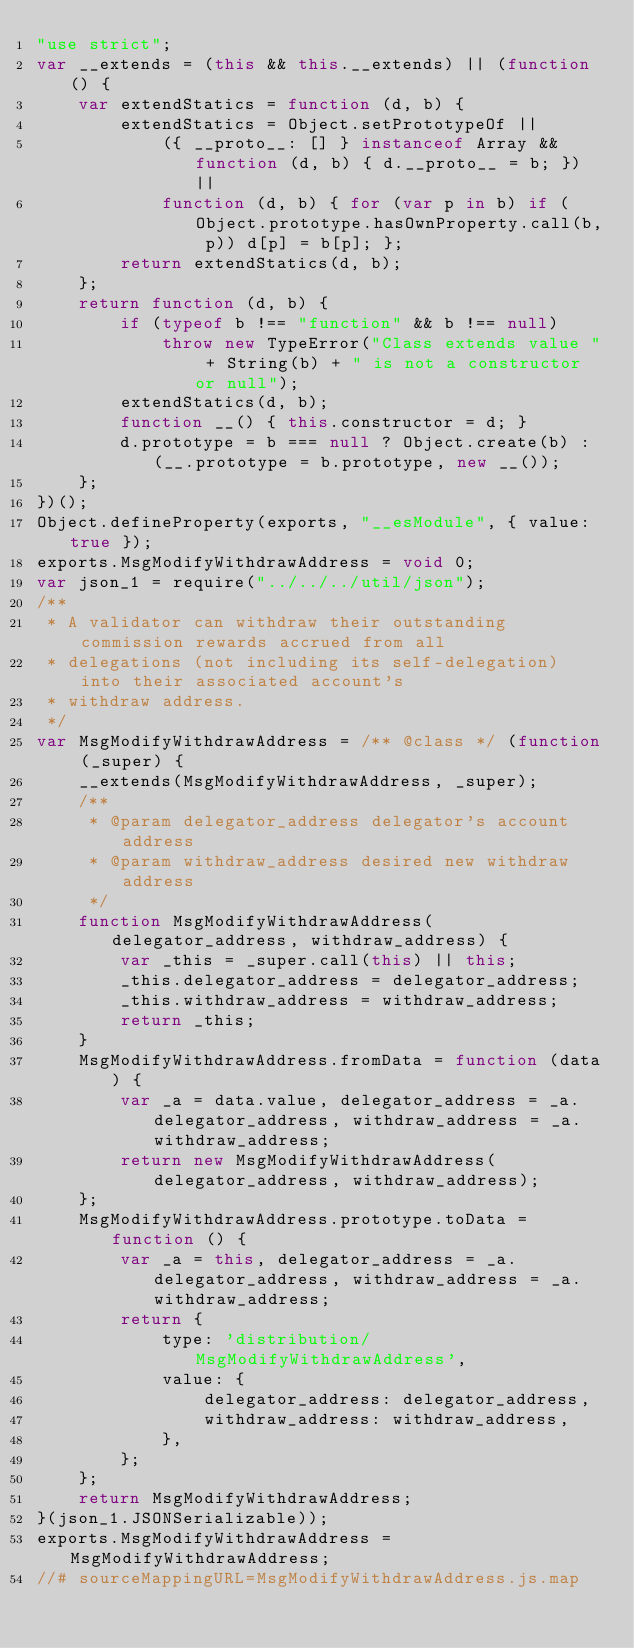<code> <loc_0><loc_0><loc_500><loc_500><_JavaScript_>"use strict";
var __extends = (this && this.__extends) || (function () {
    var extendStatics = function (d, b) {
        extendStatics = Object.setPrototypeOf ||
            ({ __proto__: [] } instanceof Array && function (d, b) { d.__proto__ = b; }) ||
            function (d, b) { for (var p in b) if (Object.prototype.hasOwnProperty.call(b, p)) d[p] = b[p]; };
        return extendStatics(d, b);
    };
    return function (d, b) {
        if (typeof b !== "function" && b !== null)
            throw new TypeError("Class extends value " + String(b) + " is not a constructor or null");
        extendStatics(d, b);
        function __() { this.constructor = d; }
        d.prototype = b === null ? Object.create(b) : (__.prototype = b.prototype, new __());
    };
})();
Object.defineProperty(exports, "__esModule", { value: true });
exports.MsgModifyWithdrawAddress = void 0;
var json_1 = require("../../../util/json");
/**
 * A validator can withdraw their outstanding commission rewards accrued from all
 * delegations (not including its self-delegation) into their associated account's
 * withdraw address.
 */
var MsgModifyWithdrawAddress = /** @class */ (function (_super) {
    __extends(MsgModifyWithdrawAddress, _super);
    /**
     * @param delegator_address delegator's account address
     * @param withdraw_address desired new withdraw address
     */
    function MsgModifyWithdrawAddress(delegator_address, withdraw_address) {
        var _this = _super.call(this) || this;
        _this.delegator_address = delegator_address;
        _this.withdraw_address = withdraw_address;
        return _this;
    }
    MsgModifyWithdrawAddress.fromData = function (data) {
        var _a = data.value, delegator_address = _a.delegator_address, withdraw_address = _a.withdraw_address;
        return new MsgModifyWithdrawAddress(delegator_address, withdraw_address);
    };
    MsgModifyWithdrawAddress.prototype.toData = function () {
        var _a = this, delegator_address = _a.delegator_address, withdraw_address = _a.withdraw_address;
        return {
            type: 'distribution/MsgModifyWithdrawAddress',
            value: {
                delegator_address: delegator_address,
                withdraw_address: withdraw_address,
            },
        };
    };
    return MsgModifyWithdrawAddress;
}(json_1.JSONSerializable));
exports.MsgModifyWithdrawAddress = MsgModifyWithdrawAddress;
//# sourceMappingURL=MsgModifyWithdrawAddress.js.map</code> 